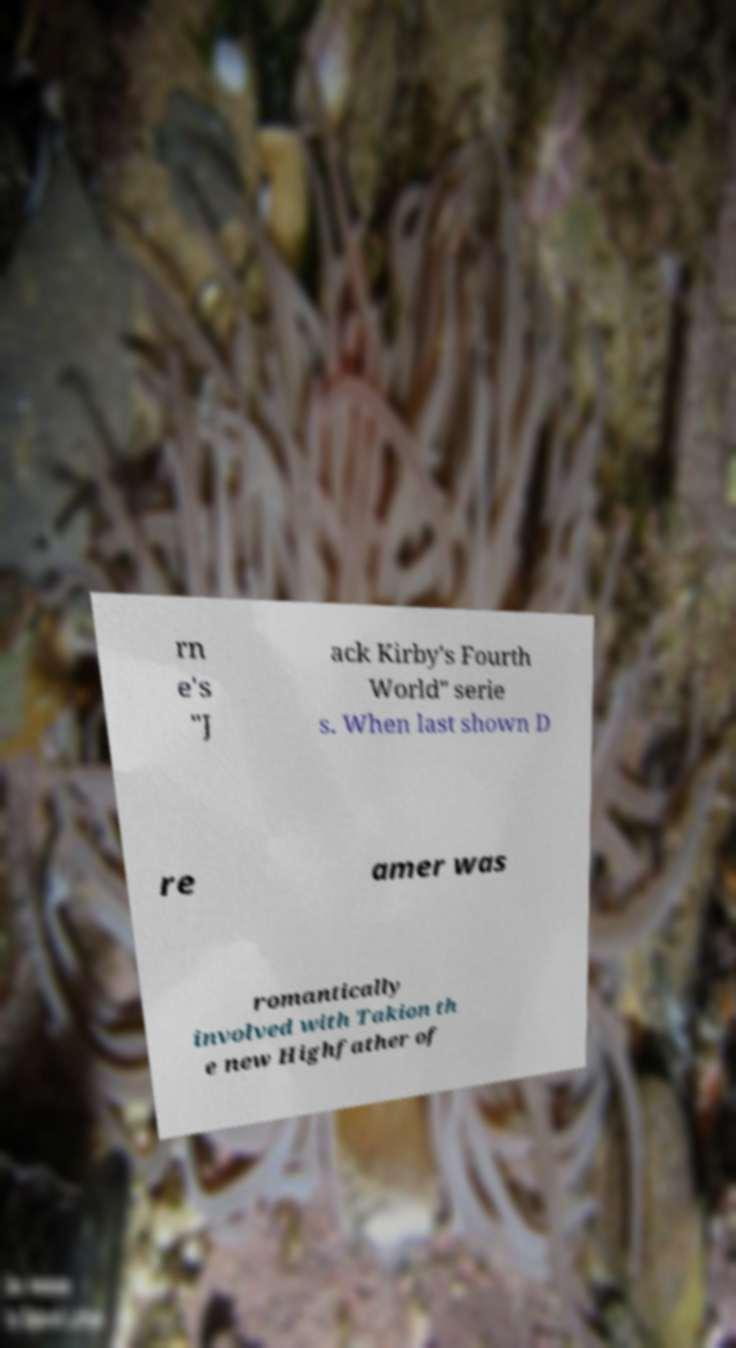For documentation purposes, I need the text within this image transcribed. Could you provide that? rn e's "J ack Kirby's Fourth World" serie s. When last shown D re amer was romantically involved with Takion th e new Highfather of 